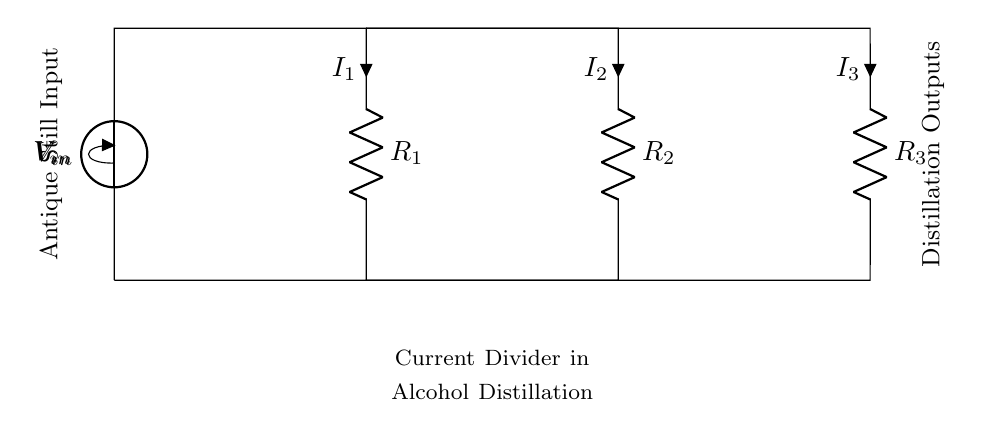What is the input voltage of this circuit? The input voltage can be found at the source labeled as V_in. This component indicates the voltage supplied to the circuit.
Answer: V_in What are the resistances present in the circuit? The resistances in the circuit are R_1, R_2, and R_3, as denoted by their labels. Each component is explicitly marked as a resistor.
Answer: R_1, R_2, R_3 How many branches are in the current divider? There are three branches stemming from the main circuit line, corresponding to R_1, R_2, and R_3. Each branch allows current to flow through separate resistors, typical for a current divider.
Answer: Three If the input voltage is constant, how does R_2 affect the current through R_1? In a current divider, if the resistance R_2 increases while maintaining a constant V_in, the current I_1 through R_1 will decrease according to the formula I_1 = V_in / R_1. This is based on the division of current in accordance with resistance values.
Answer: Decreases What does the current I_3 represent in this circuit? The current I_3 represents the flow of electric charge through resistor R_3, and it is one of the output currents in this current divider circuit. It shows how much current is directed through that specific resistor when a total current is supplied at V_in.
Answer: Output current through R_3 Which resistor has the highest current? The current through each resistor is inversely proportional to its resistance, thus the smallest resistor will have the highest current. In the circuit, without specific values, we assume I_1, I_2, or I_3's comparative values depend on R_1, R_2, R_3 respectively.
Answer: Smallest resistor 